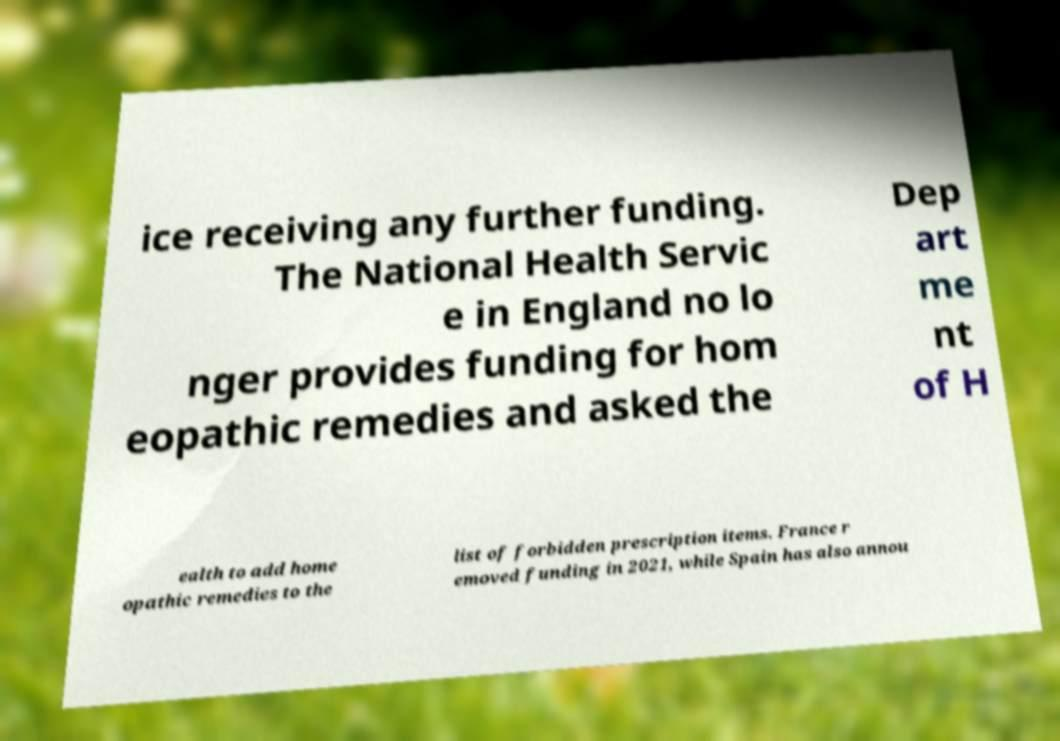There's text embedded in this image that I need extracted. Can you transcribe it verbatim? ice receiving any further funding. The National Health Servic e in England no lo nger provides funding for hom eopathic remedies and asked the Dep art me nt of H ealth to add home opathic remedies to the list of forbidden prescription items. France r emoved funding in 2021, while Spain has also annou 